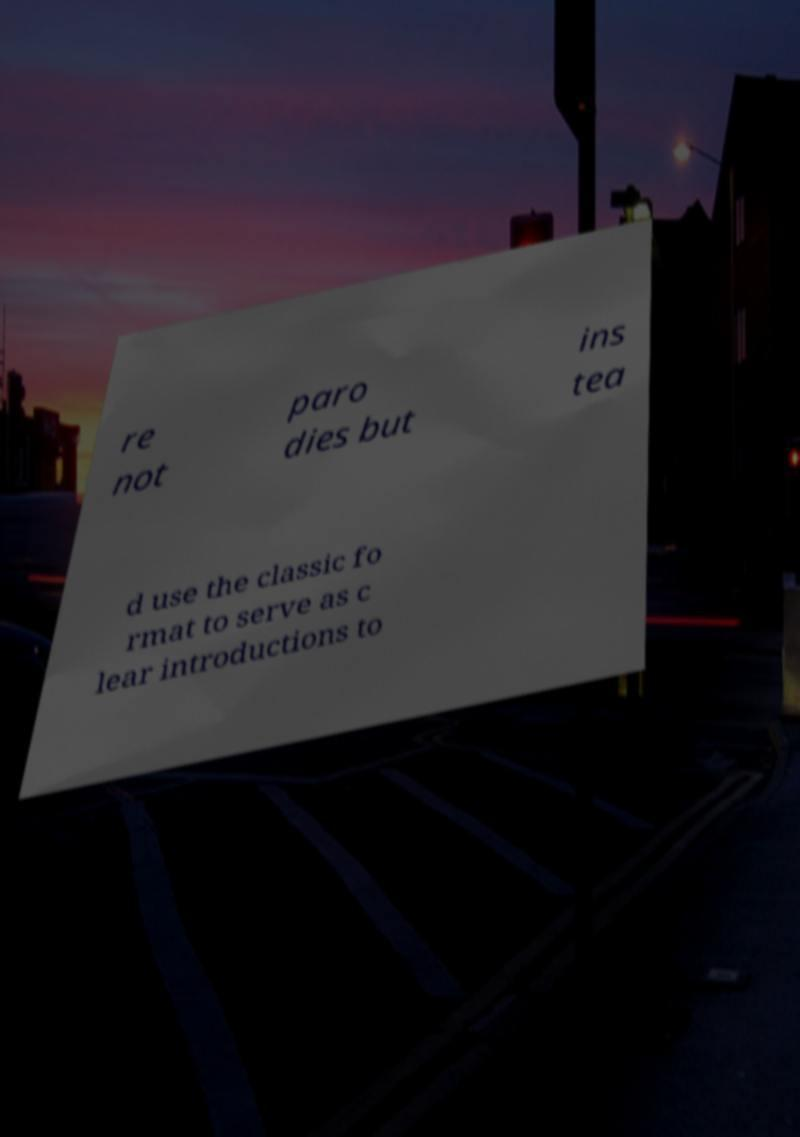Could you assist in decoding the text presented in this image and type it out clearly? re not paro dies but ins tea d use the classic fo rmat to serve as c lear introductions to 